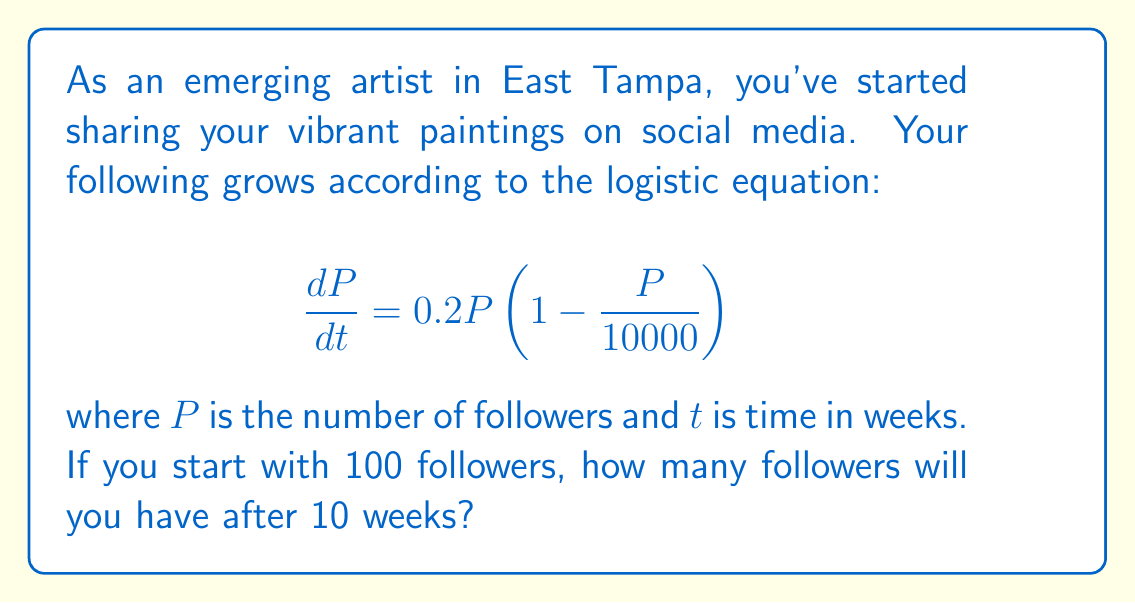Can you solve this math problem? To solve this problem, we need to use the solution to the logistic equation:

1) The general solution to the logistic equation is:

   $$P(t) = \frac{K}{1 + (\frac{K}{P_0} - 1)e^{-rt}}$$

   where $K$ is the carrying capacity, $P_0$ is the initial population, and $r$ is the growth rate.

2) From the given equation, we can identify:
   $K = 10000$ (carrying capacity)
   $r = 0.2$ (growth rate)
   $P_0 = 100$ (initial followers)

3) Substituting these values into the solution:

   $$P(t) = \frac{10000}{1 + (\frac{10000}{100} - 1)e^{-0.2t}}$$

4) Simplify:

   $$P(t) = \frac{10000}{1 + 99e^{-0.2t}}$$

5) Now, we want to find $P(10)$, so substitute $t = 10$:

   $$P(10) = \frac{10000}{1 + 99e^{-0.2(10)}}$$

6) Calculate:

   $$P(10) = \frac{10000}{1 + 99e^{-2}} \approx 729.91$$

7) Since we're dealing with followers, we round down to the nearest whole number.
Answer: 729 followers 